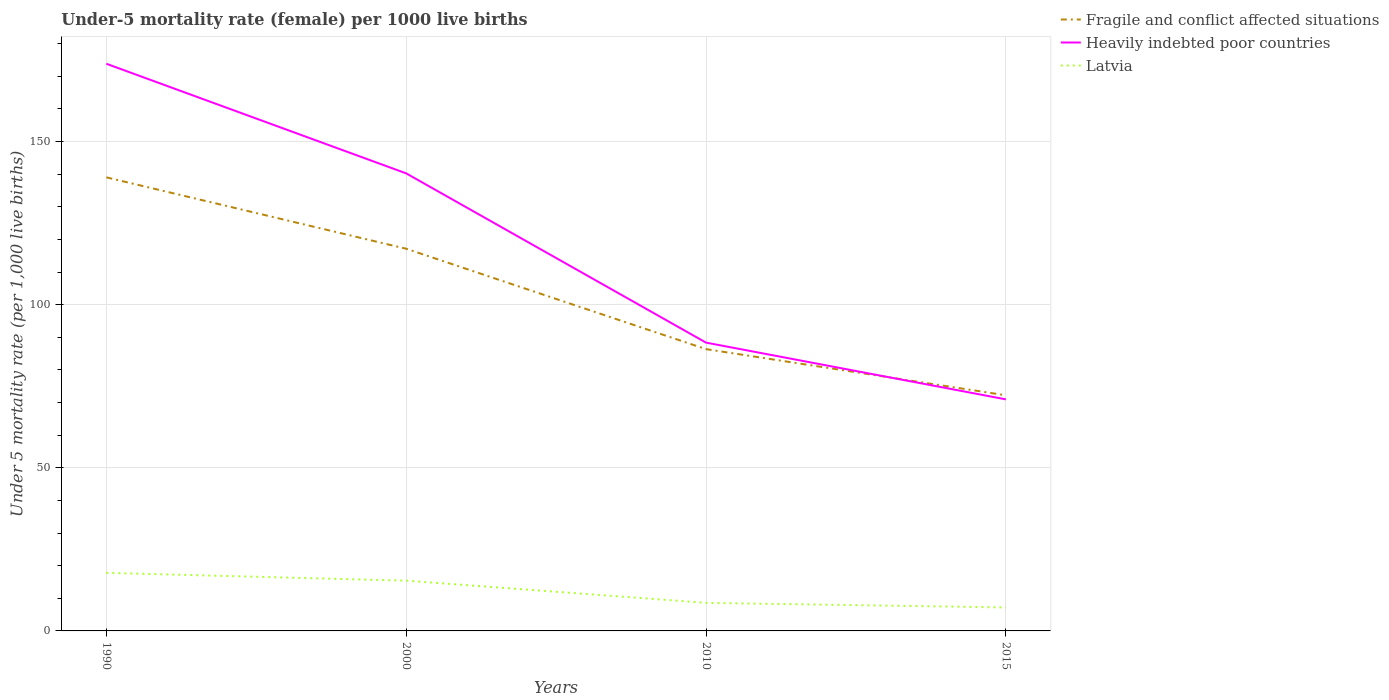How many different coloured lines are there?
Keep it short and to the point. 3. Does the line corresponding to Fragile and conflict affected situations intersect with the line corresponding to Latvia?
Keep it short and to the point. No. Is the number of lines equal to the number of legend labels?
Your response must be concise. Yes. Across all years, what is the maximum under-five mortality rate in Latvia?
Keep it short and to the point. 7.2. In which year was the under-five mortality rate in Fragile and conflict affected situations maximum?
Provide a short and direct response. 2015. What is the total under-five mortality rate in Fragile and conflict affected situations in the graph?
Offer a terse response. 14.14. What is the difference between the highest and the second highest under-five mortality rate in Heavily indebted poor countries?
Provide a succinct answer. 102.86. What is the difference between the highest and the lowest under-five mortality rate in Latvia?
Keep it short and to the point. 2. How many years are there in the graph?
Make the answer very short. 4. What is the difference between two consecutive major ticks on the Y-axis?
Provide a succinct answer. 50. Are the values on the major ticks of Y-axis written in scientific E-notation?
Your response must be concise. No. Where does the legend appear in the graph?
Your response must be concise. Top right. How many legend labels are there?
Ensure brevity in your answer.  3. What is the title of the graph?
Your answer should be very brief. Under-5 mortality rate (female) per 1000 live births. Does "St. Kitts and Nevis" appear as one of the legend labels in the graph?
Give a very brief answer. No. What is the label or title of the X-axis?
Make the answer very short. Years. What is the label or title of the Y-axis?
Your answer should be compact. Under 5 mortality rate (per 1,0 live births). What is the Under 5 mortality rate (per 1,000 live births) in Fragile and conflict affected situations in 1990?
Provide a succinct answer. 139.01. What is the Under 5 mortality rate (per 1,000 live births) in Heavily indebted poor countries in 1990?
Your answer should be compact. 173.83. What is the Under 5 mortality rate (per 1,000 live births) in Latvia in 1990?
Your answer should be very brief. 17.8. What is the Under 5 mortality rate (per 1,000 live births) of Fragile and conflict affected situations in 2000?
Make the answer very short. 117.13. What is the Under 5 mortality rate (per 1,000 live births) in Heavily indebted poor countries in 2000?
Ensure brevity in your answer.  140.23. What is the Under 5 mortality rate (per 1,000 live births) in Fragile and conflict affected situations in 2010?
Your answer should be compact. 86.36. What is the Under 5 mortality rate (per 1,000 live births) in Heavily indebted poor countries in 2010?
Give a very brief answer. 88.36. What is the Under 5 mortality rate (per 1,000 live births) in Latvia in 2010?
Make the answer very short. 8.6. What is the Under 5 mortality rate (per 1,000 live births) of Fragile and conflict affected situations in 2015?
Make the answer very short. 72.22. What is the Under 5 mortality rate (per 1,000 live births) of Heavily indebted poor countries in 2015?
Provide a short and direct response. 70.97. Across all years, what is the maximum Under 5 mortality rate (per 1,000 live births) in Fragile and conflict affected situations?
Provide a succinct answer. 139.01. Across all years, what is the maximum Under 5 mortality rate (per 1,000 live births) in Heavily indebted poor countries?
Make the answer very short. 173.83. Across all years, what is the minimum Under 5 mortality rate (per 1,000 live births) of Fragile and conflict affected situations?
Keep it short and to the point. 72.22. Across all years, what is the minimum Under 5 mortality rate (per 1,000 live births) of Heavily indebted poor countries?
Offer a terse response. 70.97. What is the total Under 5 mortality rate (per 1,000 live births) in Fragile and conflict affected situations in the graph?
Ensure brevity in your answer.  414.72. What is the total Under 5 mortality rate (per 1,000 live births) of Heavily indebted poor countries in the graph?
Your response must be concise. 473.39. What is the total Under 5 mortality rate (per 1,000 live births) of Latvia in the graph?
Give a very brief answer. 49. What is the difference between the Under 5 mortality rate (per 1,000 live births) in Fragile and conflict affected situations in 1990 and that in 2000?
Offer a terse response. 21.88. What is the difference between the Under 5 mortality rate (per 1,000 live births) in Heavily indebted poor countries in 1990 and that in 2000?
Keep it short and to the point. 33.59. What is the difference between the Under 5 mortality rate (per 1,000 live births) in Fragile and conflict affected situations in 1990 and that in 2010?
Keep it short and to the point. 52.65. What is the difference between the Under 5 mortality rate (per 1,000 live births) in Heavily indebted poor countries in 1990 and that in 2010?
Make the answer very short. 85.47. What is the difference between the Under 5 mortality rate (per 1,000 live births) of Latvia in 1990 and that in 2010?
Provide a succinct answer. 9.2. What is the difference between the Under 5 mortality rate (per 1,000 live births) in Fragile and conflict affected situations in 1990 and that in 2015?
Offer a very short reply. 66.8. What is the difference between the Under 5 mortality rate (per 1,000 live births) in Heavily indebted poor countries in 1990 and that in 2015?
Your answer should be very brief. 102.86. What is the difference between the Under 5 mortality rate (per 1,000 live births) of Fragile and conflict affected situations in 2000 and that in 2010?
Provide a short and direct response. 30.77. What is the difference between the Under 5 mortality rate (per 1,000 live births) of Heavily indebted poor countries in 2000 and that in 2010?
Make the answer very short. 51.87. What is the difference between the Under 5 mortality rate (per 1,000 live births) of Latvia in 2000 and that in 2010?
Keep it short and to the point. 6.8. What is the difference between the Under 5 mortality rate (per 1,000 live births) of Fragile and conflict affected situations in 2000 and that in 2015?
Your answer should be very brief. 44.92. What is the difference between the Under 5 mortality rate (per 1,000 live births) in Heavily indebted poor countries in 2000 and that in 2015?
Provide a succinct answer. 69.27. What is the difference between the Under 5 mortality rate (per 1,000 live births) of Fragile and conflict affected situations in 2010 and that in 2015?
Keep it short and to the point. 14.14. What is the difference between the Under 5 mortality rate (per 1,000 live births) in Heavily indebted poor countries in 2010 and that in 2015?
Make the answer very short. 17.39. What is the difference between the Under 5 mortality rate (per 1,000 live births) in Fragile and conflict affected situations in 1990 and the Under 5 mortality rate (per 1,000 live births) in Heavily indebted poor countries in 2000?
Give a very brief answer. -1.22. What is the difference between the Under 5 mortality rate (per 1,000 live births) in Fragile and conflict affected situations in 1990 and the Under 5 mortality rate (per 1,000 live births) in Latvia in 2000?
Offer a terse response. 123.61. What is the difference between the Under 5 mortality rate (per 1,000 live births) of Heavily indebted poor countries in 1990 and the Under 5 mortality rate (per 1,000 live births) of Latvia in 2000?
Offer a very short reply. 158.43. What is the difference between the Under 5 mortality rate (per 1,000 live births) in Fragile and conflict affected situations in 1990 and the Under 5 mortality rate (per 1,000 live births) in Heavily indebted poor countries in 2010?
Provide a succinct answer. 50.65. What is the difference between the Under 5 mortality rate (per 1,000 live births) of Fragile and conflict affected situations in 1990 and the Under 5 mortality rate (per 1,000 live births) of Latvia in 2010?
Give a very brief answer. 130.41. What is the difference between the Under 5 mortality rate (per 1,000 live births) of Heavily indebted poor countries in 1990 and the Under 5 mortality rate (per 1,000 live births) of Latvia in 2010?
Your response must be concise. 165.23. What is the difference between the Under 5 mortality rate (per 1,000 live births) in Fragile and conflict affected situations in 1990 and the Under 5 mortality rate (per 1,000 live births) in Heavily indebted poor countries in 2015?
Your answer should be compact. 68.04. What is the difference between the Under 5 mortality rate (per 1,000 live births) in Fragile and conflict affected situations in 1990 and the Under 5 mortality rate (per 1,000 live births) in Latvia in 2015?
Your response must be concise. 131.81. What is the difference between the Under 5 mortality rate (per 1,000 live births) of Heavily indebted poor countries in 1990 and the Under 5 mortality rate (per 1,000 live births) of Latvia in 2015?
Make the answer very short. 166.63. What is the difference between the Under 5 mortality rate (per 1,000 live births) in Fragile and conflict affected situations in 2000 and the Under 5 mortality rate (per 1,000 live births) in Heavily indebted poor countries in 2010?
Your answer should be compact. 28.77. What is the difference between the Under 5 mortality rate (per 1,000 live births) of Fragile and conflict affected situations in 2000 and the Under 5 mortality rate (per 1,000 live births) of Latvia in 2010?
Offer a very short reply. 108.53. What is the difference between the Under 5 mortality rate (per 1,000 live births) of Heavily indebted poor countries in 2000 and the Under 5 mortality rate (per 1,000 live births) of Latvia in 2010?
Give a very brief answer. 131.63. What is the difference between the Under 5 mortality rate (per 1,000 live births) of Fragile and conflict affected situations in 2000 and the Under 5 mortality rate (per 1,000 live births) of Heavily indebted poor countries in 2015?
Give a very brief answer. 46.17. What is the difference between the Under 5 mortality rate (per 1,000 live births) in Fragile and conflict affected situations in 2000 and the Under 5 mortality rate (per 1,000 live births) in Latvia in 2015?
Offer a terse response. 109.93. What is the difference between the Under 5 mortality rate (per 1,000 live births) of Heavily indebted poor countries in 2000 and the Under 5 mortality rate (per 1,000 live births) of Latvia in 2015?
Your answer should be compact. 133.03. What is the difference between the Under 5 mortality rate (per 1,000 live births) of Fragile and conflict affected situations in 2010 and the Under 5 mortality rate (per 1,000 live births) of Heavily indebted poor countries in 2015?
Make the answer very short. 15.39. What is the difference between the Under 5 mortality rate (per 1,000 live births) of Fragile and conflict affected situations in 2010 and the Under 5 mortality rate (per 1,000 live births) of Latvia in 2015?
Your response must be concise. 79.16. What is the difference between the Under 5 mortality rate (per 1,000 live births) in Heavily indebted poor countries in 2010 and the Under 5 mortality rate (per 1,000 live births) in Latvia in 2015?
Your answer should be compact. 81.16. What is the average Under 5 mortality rate (per 1,000 live births) in Fragile and conflict affected situations per year?
Keep it short and to the point. 103.68. What is the average Under 5 mortality rate (per 1,000 live births) in Heavily indebted poor countries per year?
Offer a very short reply. 118.35. What is the average Under 5 mortality rate (per 1,000 live births) in Latvia per year?
Provide a short and direct response. 12.25. In the year 1990, what is the difference between the Under 5 mortality rate (per 1,000 live births) of Fragile and conflict affected situations and Under 5 mortality rate (per 1,000 live births) of Heavily indebted poor countries?
Offer a very short reply. -34.81. In the year 1990, what is the difference between the Under 5 mortality rate (per 1,000 live births) of Fragile and conflict affected situations and Under 5 mortality rate (per 1,000 live births) of Latvia?
Give a very brief answer. 121.21. In the year 1990, what is the difference between the Under 5 mortality rate (per 1,000 live births) in Heavily indebted poor countries and Under 5 mortality rate (per 1,000 live births) in Latvia?
Make the answer very short. 156.03. In the year 2000, what is the difference between the Under 5 mortality rate (per 1,000 live births) of Fragile and conflict affected situations and Under 5 mortality rate (per 1,000 live births) of Heavily indebted poor countries?
Your response must be concise. -23.1. In the year 2000, what is the difference between the Under 5 mortality rate (per 1,000 live births) of Fragile and conflict affected situations and Under 5 mortality rate (per 1,000 live births) of Latvia?
Your response must be concise. 101.73. In the year 2000, what is the difference between the Under 5 mortality rate (per 1,000 live births) in Heavily indebted poor countries and Under 5 mortality rate (per 1,000 live births) in Latvia?
Your answer should be compact. 124.83. In the year 2010, what is the difference between the Under 5 mortality rate (per 1,000 live births) of Fragile and conflict affected situations and Under 5 mortality rate (per 1,000 live births) of Heavily indebted poor countries?
Give a very brief answer. -2. In the year 2010, what is the difference between the Under 5 mortality rate (per 1,000 live births) in Fragile and conflict affected situations and Under 5 mortality rate (per 1,000 live births) in Latvia?
Provide a short and direct response. 77.76. In the year 2010, what is the difference between the Under 5 mortality rate (per 1,000 live births) of Heavily indebted poor countries and Under 5 mortality rate (per 1,000 live births) of Latvia?
Your response must be concise. 79.76. In the year 2015, what is the difference between the Under 5 mortality rate (per 1,000 live births) in Fragile and conflict affected situations and Under 5 mortality rate (per 1,000 live births) in Heavily indebted poor countries?
Keep it short and to the point. 1.25. In the year 2015, what is the difference between the Under 5 mortality rate (per 1,000 live births) of Fragile and conflict affected situations and Under 5 mortality rate (per 1,000 live births) of Latvia?
Make the answer very short. 65.02. In the year 2015, what is the difference between the Under 5 mortality rate (per 1,000 live births) in Heavily indebted poor countries and Under 5 mortality rate (per 1,000 live births) in Latvia?
Your response must be concise. 63.77. What is the ratio of the Under 5 mortality rate (per 1,000 live births) in Fragile and conflict affected situations in 1990 to that in 2000?
Give a very brief answer. 1.19. What is the ratio of the Under 5 mortality rate (per 1,000 live births) in Heavily indebted poor countries in 1990 to that in 2000?
Keep it short and to the point. 1.24. What is the ratio of the Under 5 mortality rate (per 1,000 live births) of Latvia in 1990 to that in 2000?
Keep it short and to the point. 1.16. What is the ratio of the Under 5 mortality rate (per 1,000 live births) in Fragile and conflict affected situations in 1990 to that in 2010?
Keep it short and to the point. 1.61. What is the ratio of the Under 5 mortality rate (per 1,000 live births) in Heavily indebted poor countries in 1990 to that in 2010?
Provide a succinct answer. 1.97. What is the ratio of the Under 5 mortality rate (per 1,000 live births) in Latvia in 1990 to that in 2010?
Your answer should be very brief. 2.07. What is the ratio of the Under 5 mortality rate (per 1,000 live births) in Fragile and conflict affected situations in 1990 to that in 2015?
Provide a short and direct response. 1.93. What is the ratio of the Under 5 mortality rate (per 1,000 live births) of Heavily indebted poor countries in 1990 to that in 2015?
Provide a short and direct response. 2.45. What is the ratio of the Under 5 mortality rate (per 1,000 live births) of Latvia in 1990 to that in 2015?
Make the answer very short. 2.47. What is the ratio of the Under 5 mortality rate (per 1,000 live births) in Fragile and conflict affected situations in 2000 to that in 2010?
Give a very brief answer. 1.36. What is the ratio of the Under 5 mortality rate (per 1,000 live births) of Heavily indebted poor countries in 2000 to that in 2010?
Give a very brief answer. 1.59. What is the ratio of the Under 5 mortality rate (per 1,000 live births) of Latvia in 2000 to that in 2010?
Give a very brief answer. 1.79. What is the ratio of the Under 5 mortality rate (per 1,000 live births) of Fragile and conflict affected situations in 2000 to that in 2015?
Your answer should be very brief. 1.62. What is the ratio of the Under 5 mortality rate (per 1,000 live births) of Heavily indebted poor countries in 2000 to that in 2015?
Provide a succinct answer. 1.98. What is the ratio of the Under 5 mortality rate (per 1,000 live births) in Latvia in 2000 to that in 2015?
Provide a short and direct response. 2.14. What is the ratio of the Under 5 mortality rate (per 1,000 live births) in Fragile and conflict affected situations in 2010 to that in 2015?
Ensure brevity in your answer.  1.2. What is the ratio of the Under 5 mortality rate (per 1,000 live births) of Heavily indebted poor countries in 2010 to that in 2015?
Your answer should be compact. 1.25. What is the ratio of the Under 5 mortality rate (per 1,000 live births) in Latvia in 2010 to that in 2015?
Your answer should be compact. 1.19. What is the difference between the highest and the second highest Under 5 mortality rate (per 1,000 live births) in Fragile and conflict affected situations?
Provide a succinct answer. 21.88. What is the difference between the highest and the second highest Under 5 mortality rate (per 1,000 live births) in Heavily indebted poor countries?
Provide a succinct answer. 33.59. What is the difference between the highest and the lowest Under 5 mortality rate (per 1,000 live births) in Fragile and conflict affected situations?
Provide a short and direct response. 66.8. What is the difference between the highest and the lowest Under 5 mortality rate (per 1,000 live births) in Heavily indebted poor countries?
Make the answer very short. 102.86. What is the difference between the highest and the lowest Under 5 mortality rate (per 1,000 live births) in Latvia?
Your response must be concise. 10.6. 